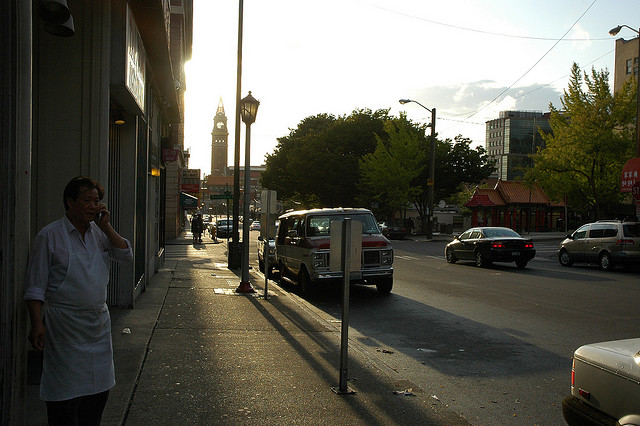Extract all visible text content from this image. S 